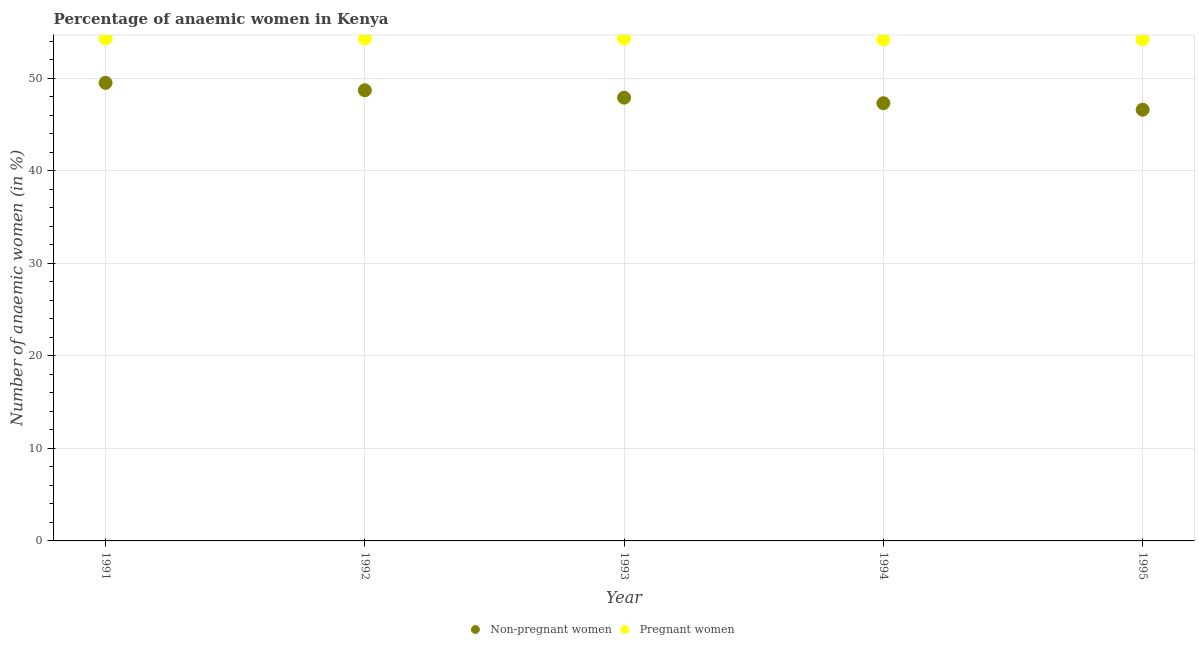What is the percentage of non-pregnant anaemic women in 1991?
Keep it short and to the point. 49.5. Across all years, what is the maximum percentage of non-pregnant anaemic women?
Your response must be concise. 49.5. Across all years, what is the minimum percentage of non-pregnant anaemic women?
Give a very brief answer. 46.6. In which year was the percentage of pregnant anaemic women minimum?
Make the answer very short. 1994. What is the total percentage of pregnant anaemic women in the graph?
Your response must be concise. 271.3. What is the difference between the percentage of pregnant anaemic women in 1993 and that in 1994?
Your answer should be compact. 0.1. What is the difference between the percentage of pregnant anaemic women in 1993 and the percentage of non-pregnant anaemic women in 1995?
Make the answer very short. 7.7. What is the average percentage of pregnant anaemic women per year?
Your response must be concise. 54.26. In the year 1994, what is the difference between the percentage of non-pregnant anaemic women and percentage of pregnant anaemic women?
Your response must be concise. -6.9. What is the ratio of the percentage of non-pregnant anaemic women in 1994 to that in 1995?
Provide a short and direct response. 1.02. What is the difference between the highest and the second highest percentage of non-pregnant anaemic women?
Keep it short and to the point. 0.8. What is the difference between the highest and the lowest percentage of pregnant anaemic women?
Your answer should be very brief. 0.1. Does the percentage of pregnant anaemic women monotonically increase over the years?
Your answer should be very brief. No. Is the percentage of pregnant anaemic women strictly greater than the percentage of non-pregnant anaemic women over the years?
Offer a very short reply. Yes. Is the percentage of non-pregnant anaemic women strictly less than the percentage of pregnant anaemic women over the years?
Make the answer very short. Yes. Are the values on the major ticks of Y-axis written in scientific E-notation?
Make the answer very short. No. Does the graph contain any zero values?
Ensure brevity in your answer.  No. Does the graph contain grids?
Your answer should be compact. Yes. How are the legend labels stacked?
Your response must be concise. Horizontal. What is the title of the graph?
Keep it short and to the point. Percentage of anaemic women in Kenya. What is the label or title of the Y-axis?
Make the answer very short. Number of anaemic women (in %). What is the Number of anaemic women (in %) of Non-pregnant women in 1991?
Provide a short and direct response. 49.5. What is the Number of anaemic women (in %) of Pregnant women in 1991?
Keep it short and to the point. 54.3. What is the Number of anaemic women (in %) in Non-pregnant women in 1992?
Your answer should be compact. 48.7. What is the Number of anaemic women (in %) of Pregnant women in 1992?
Provide a succinct answer. 54.3. What is the Number of anaemic women (in %) in Non-pregnant women in 1993?
Give a very brief answer. 47.9. What is the Number of anaemic women (in %) in Pregnant women in 1993?
Offer a terse response. 54.3. What is the Number of anaemic women (in %) of Non-pregnant women in 1994?
Your answer should be compact. 47.3. What is the Number of anaemic women (in %) in Pregnant women in 1994?
Offer a terse response. 54.2. What is the Number of anaemic women (in %) of Non-pregnant women in 1995?
Keep it short and to the point. 46.6. What is the Number of anaemic women (in %) of Pregnant women in 1995?
Your response must be concise. 54.2. Across all years, what is the maximum Number of anaemic women (in %) of Non-pregnant women?
Make the answer very short. 49.5. Across all years, what is the maximum Number of anaemic women (in %) of Pregnant women?
Provide a succinct answer. 54.3. Across all years, what is the minimum Number of anaemic women (in %) in Non-pregnant women?
Your answer should be very brief. 46.6. Across all years, what is the minimum Number of anaemic women (in %) in Pregnant women?
Make the answer very short. 54.2. What is the total Number of anaemic women (in %) in Non-pregnant women in the graph?
Keep it short and to the point. 240. What is the total Number of anaemic women (in %) of Pregnant women in the graph?
Your answer should be compact. 271.3. What is the difference between the Number of anaemic women (in %) in Non-pregnant women in 1991 and that in 1995?
Make the answer very short. 2.9. What is the difference between the Number of anaemic women (in %) of Pregnant women in 1991 and that in 1995?
Make the answer very short. 0.1. What is the difference between the Number of anaemic women (in %) of Non-pregnant women in 1992 and that in 1993?
Provide a short and direct response. 0.8. What is the difference between the Number of anaemic women (in %) in Pregnant women in 1992 and that in 1994?
Provide a succinct answer. 0.1. What is the difference between the Number of anaemic women (in %) in Non-pregnant women in 1993 and that in 1994?
Give a very brief answer. 0.6. What is the difference between the Number of anaemic women (in %) of Pregnant women in 1993 and that in 1994?
Offer a very short reply. 0.1. What is the difference between the Number of anaemic women (in %) in Non-pregnant women in 1993 and the Number of anaemic women (in %) in Pregnant women in 1994?
Provide a succinct answer. -6.3. What is the average Number of anaemic women (in %) in Non-pregnant women per year?
Offer a very short reply. 48. What is the average Number of anaemic women (in %) in Pregnant women per year?
Your answer should be compact. 54.26. In the year 1994, what is the difference between the Number of anaemic women (in %) in Non-pregnant women and Number of anaemic women (in %) in Pregnant women?
Make the answer very short. -6.9. What is the ratio of the Number of anaemic women (in %) of Non-pregnant women in 1991 to that in 1992?
Your answer should be very brief. 1.02. What is the ratio of the Number of anaemic women (in %) of Pregnant women in 1991 to that in 1992?
Offer a very short reply. 1. What is the ratio of the Number of anaemic women (in %) in Non-pregnant women in 1991 to that in 1993?
Offer a very short reply. 1.03. What is the ratio of the Number of anaemic women (in %) of Non-pregnant women in 1991 to that in 1994?
Your answer should be compact. 1.05. What is the ratio of the Number of anaemic women (in %) of Pregnant women in 1991 to that in 1994?
Your response must be concise. 1. What is the ratio of the Number of anaemic women (in %) of Non-pregnant women in 1991 to that in 1995?
Your response must be concise. 1.06. What is the ratio of the Number of anaemic women (in %) of Pregnant women in 1991 to that in 1995?
Give a very brief answer. 1. What is the ratio of the Number of anaemic women (in %) of Non-pregnant women in 1992 to that in 1993?
Your answer should be very brief. 1.02. What is the ratio of the Number of anaemic women (in %) of Pregnant women in 1992 to that in 1993?
Offer a terse response. 1. What is the ratio of the Number of anaemic women (in %) in Non-pregnant women in 1992 to that in 1994?
Ensure brevity in your answer.  1.03. What is the ratio of the Number of anaemic women (in %) in Non-pregnant women in 1992 to that in 1995?
Your response must be concise. 1.05. What is the ratio of the Number of anaemic women (in %) in Pregnant women in 1992 to that in 1995?
Your response must be concise. 1. What is the ratio of the Number of anaemic women (in %) of Non-pregnant women in 1993 to that in 1994?
Give a very brief answer. 1.01. What is the ratio of the Number of anaemic women (in %) in Non-pregnant women in 1993 to that in 1995?
Your response must be concise. 1.03. What is the ratio of the Number of anaemic women (in %) in Pregnant women in 1993 to that in 1995?
Provide a short and direct response. 1. What is the ratio of the Number of anaemic women (in %) in Non-pregnant women in 1994 to that in 1995?
Your answer should be compact. 1.01. What is the difference between the highest and the second highest Number of anaemic women (in %) in Non-pregnant women?
Your answer should be very brief. 0.8. What is the difference between the highest and the lowest Number of anaemic women (in %) in Non-pregnant women?
Provide a succinct answer. 2.9. What is the difference between the highest and the lowest Number of anaemic women (in %) of Pregnant women?
Provide a short and direct response. 0.1. 